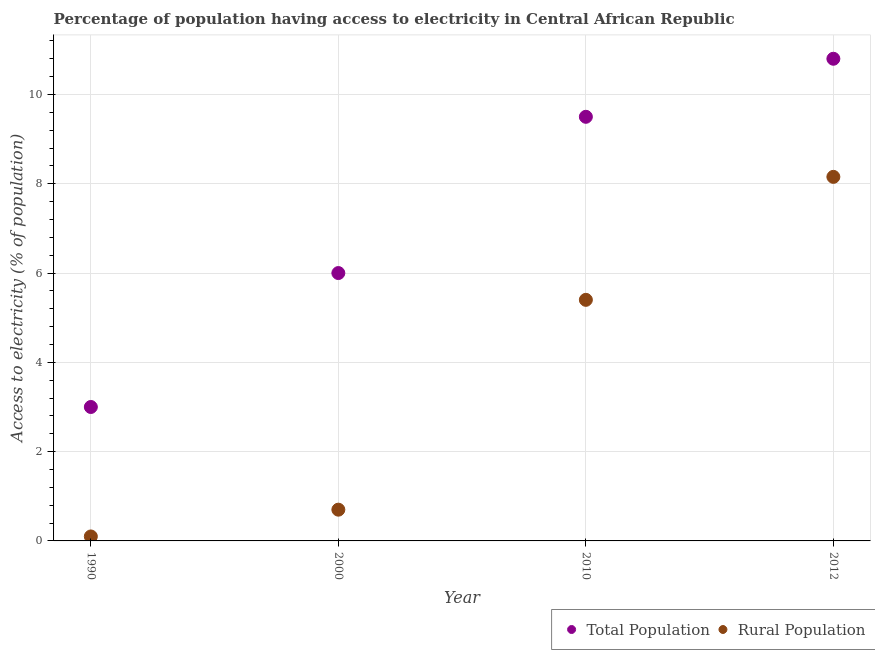How many different coloured dotlines are there?
Keep it short and to the point. 2. Across all years, what is the maximum percentage of rural population having access to electricity?
Offer a terse response. 8.15. In which year was the percentage of rural population having access to electricity minimum?
Your answer should be very brief. 1990. What is the total percentage of population having access to electricity in the graph?
Your answer should be compact. 29.3. What is the average percentage of population having access to electricity per year?
Ensure brevity in your answer.  7.33. In the year 1990, what is the difference between the percentage of rural population having access to electricity and percentage of population having access to electricity?
Offer a very short reply. -2.9. What is the ratio of the percentage of rural population having access to electricity in 1990 to that in 2010?
Provide a short and direct response. 0.02. Is the percentage of rural population having access to electricity in 1990 less than that in 2000?
Your answer should be very brief. Yes. Is the difference between the percentage of population having access to electricity in 1990 and 2000 greater than the difference between the percentage of rural population having access to electricity in 1990 and 2000?
Keep it short and to the point. No. What is the difference between the highest and the second highest percentage of rural population having access to electricity?
Your answer should be compact. 2.75. What is the difference between the highest and the lowest percentage of population having access to electricity?
Your answer should be very brief. 7.8. In how many years, is the percentage of population having access to electricity greater than the average percentage of population having access to electricity taken over all years?
Offer a terse response. 2. Is the percentage of population having access to electricity strictly greater than the percentage of rural population having access to electricity over the years?
Offer a very short reply. Yes. Is the percentage of population having access to electricity strictly less than the percentage of rural population having access to electricity over the years?
Make the answer very short. No. How many dotlines are there?
Give a very brief answer. 2. How many years are there in the graph?
Offer a terse response. 4. What is the difference between two consecutive major ticks on the Y-axis?
Make the answer very short. 2. Are the values on the major ticks of Y-axis written in scientific E-notation?
Ensure brevity in your answer.  No. Does the graph contain any zero values?
Your answer should be compact. No. What is the title of the graph?
Your answer should be very brief. Percentage of population having access to electricity in Central African Republic. What is the label or title of the Y-axis?
Provide a succinct answer. Access to electricity (% of population). What is the Access to electricity (% of population) of Total Population in 2000?
Your response must be concise. 6. What is the Access to electricity (% of population) in Total Population in 2010?
Give a very brief answer. 9.5. What is the Access to electricity (% of population) of Rural Population in 2012?
Ensure brevity in your answer.  8.15. Across all years, what is the maximum Access to electricity (% of population) in Rural Population?
Keep it short and to the point. 8.15. Across all years, what is the minimum Access to electricity (% of population) in Total Population?
Provide a succinct answer. 3. What is the total Access to electricity (% of population) in Total Population in the graph?
Your answer should be compact. 29.3. What is the total Access to electricity (% of population) of Rural Population in the graph?
Keep it short and to the point. 14.35. What is the difference between the Access to electricity (% of population) in Rural Population in 1990 and that in 2000?
Your answer should be very brief. -0.6. What is the difference between the Access to electricity (% of population) in Total Population in 1990 and that in 2012?
Your response must be concise. -7.8. What is the difference between the Access to electricity (% of population) in Rural Population in 1990 and that in 2012?
Provide a short and direct response. -8.05. What is the difference between the Access to electricity (% of population) in Total Population in 2000 and that in 2010?
Provide a short and direct response. -3.5. What is the difference between the Access to electricity (% of population) of Rural Population in 2000 and that in 2010?
Make the answer very short. -4.7. What is the difference between the Access to electricity (% of population) of Total Population in 2000 and that in 2012?
Ensure brevity in your answer.  -4.8. What is the difference between the Access to electricity (% of population) in Rural Population in 2000 and that in 2012?
Give a very brief answer. -7.45. What is the difference between the Access to electricity (% of population) of Rural Population in 2010 and that in 2012?
Ensure brevity in your answer.  -2.75. What is the difference between the Access to electricity (% of population) of Total Population in 1990 and the Access to electricity (% of population) of Rural Population in 2000?
Give a very brief answer. 2.3. What is the difference between the Access to electricity (% of population) in Total Population in 1990 and the Access to electricity (% of population) in Rural Population in 2010?
Ensure brevity in your answer.  -2.4. What is the difference between the Access to electricity (% of population) in Total Population in 1990 and the Access to electricity (% of population) in Rural Population in 2012?
Your answer should be compact. -5.15. What is the difference between the Access to electricity (% of population) of Total Population in 2000 and the Access to electricity (% of population) of Rural Population in 2010?
Your answer should be compact. 0.6. What is the difference between the Access to electricity (% of population) in Total Population in 2000 and the Access to electricity (% of population) in Rural Population in 2012?
Your answer should be very brief. -2.15. What is the difference between the Access to electricity (% of population) of Total Population in 2010 and the Access to electricity (% of population) of Rural Population in 2012?
Provide a succinct answer. 1.35. What is the average Access to electricity (% of population) in Total Population per year?
Offer a terse response. 7.33. What is the average Access to electricity (% of population) of Rural Population per year?
Your answer should be very brief. 3.59. In the year 2000, what is the difference between the Access to electricity (% of population) of Total Population and Access to electricity (% of population) of Rural Population?
Make the answer very short. 5.3. In the year 2010, what is the difference between the Access to electricity (% of population) of Total Population and Access to electricity (% of population) of Rural Population?
Your answer should be compact. 4.1. In the year 2012, what is the difference between the Access to electricity (% of population) of Total Population and Access to electricity (% of population) of Rural Population?
Keep it short and to the point. 2.65. What is the ratio of the Access to electricity (% of population) in Total Population in 1990 to that in 2000?
Ensure brevity in your answer.  0.5. What is the ratio of the Access to electricity (% of population) of Rural Population in 1990 to that in 2000?
Provide a short and direct response. 0.14. What is the ratio of the Access to electricity (% of population) of Total Population in 1990 to that in 2010?
Your answer should be compact. 0.32. What is the ratio of the Access to electricity (% of population) of Rural Population in 1990 to that in 2010?
Your answer should be very brief. 0.02. What is the ratio of the Access to electricity (% of population) in Total Population in 1990 to that in 2012?
Keep it short and to the point. 0.28. What is the ratio of the Access to electricity (% of population) of Rural Population in 1990 to that in 2012?
Your response must be concise. 0.01. What is the ratio of the Access to electricity (% of population) in Total Population in 2000 to that in 2010?
Keep it short and to the point. 0.63. What is the ratio of the Access to electricity (% of population) in Rural Population in 2000 to that in 2010?
Offer a terse response. 0.13. What is the ratio of the Access to electricity (% of population) in Total Population in 2000 to that in 2012?
Give a very brief answer. 0.56. What is the ratio of the Access to electricity (% of population) in Rural Population in 2000 to that in 2012?
Provide a short and direct response. 0.09. What is the ratio of the Access to electricity (% of population) of Total Population in 2010 to that in 2012?
Offer a very short reply. 0.88. What is the ratio of the Access to electricity (% of population) of Rural Population in 2010 to that in 2012?
Provide a short and direct response. 0.66. What is the difference between the highest and the second highest Access to electricity (% of population) of Rural Population?
Your answer should be very brief. 2.75. What is the difference between the highest and the lowest Access to electricity (% of population) of Rural Population?
Your answer should be compact. 8.05. 